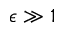<formula> <loc_0><loc_0><loc_500><loc_500>\epsilon \gg 1</formula> 